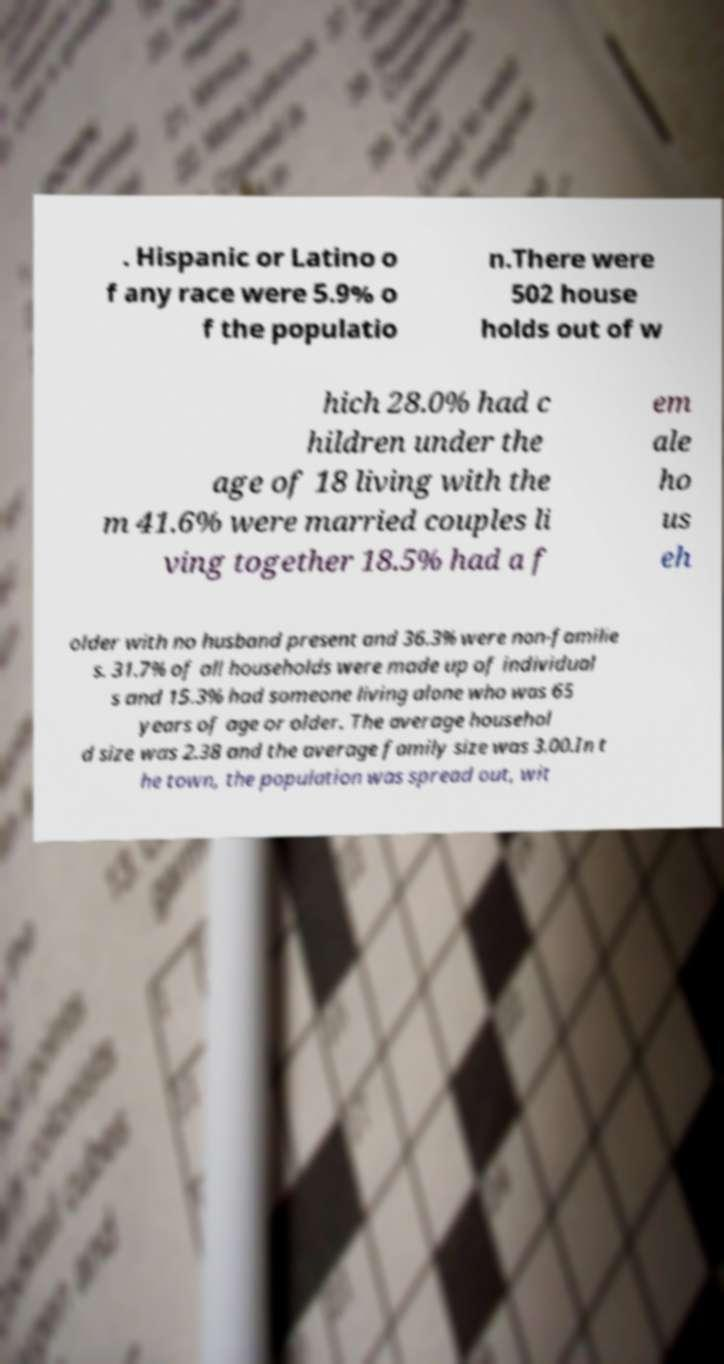There's text embedded in this image that I need extracted. Can you transcribe it verbatim? . Hispanic or Latino o f any race were 5.9% o f the populatio n.There were 502 house holds out of w hich 28.0% had c hildren under the age of 18 living with the m 41.6% were married couples li ving together 18.5% had a f em ale ho us eh older with no husband present and 36.3% were non-familie s. 31.7% of all households were made up of individual s and 15.3% had someone living alone who was 65 years of age or older. The average househol d size was 2.38 and the average family size was 3.00.In t he town, the population was spread out, wit 